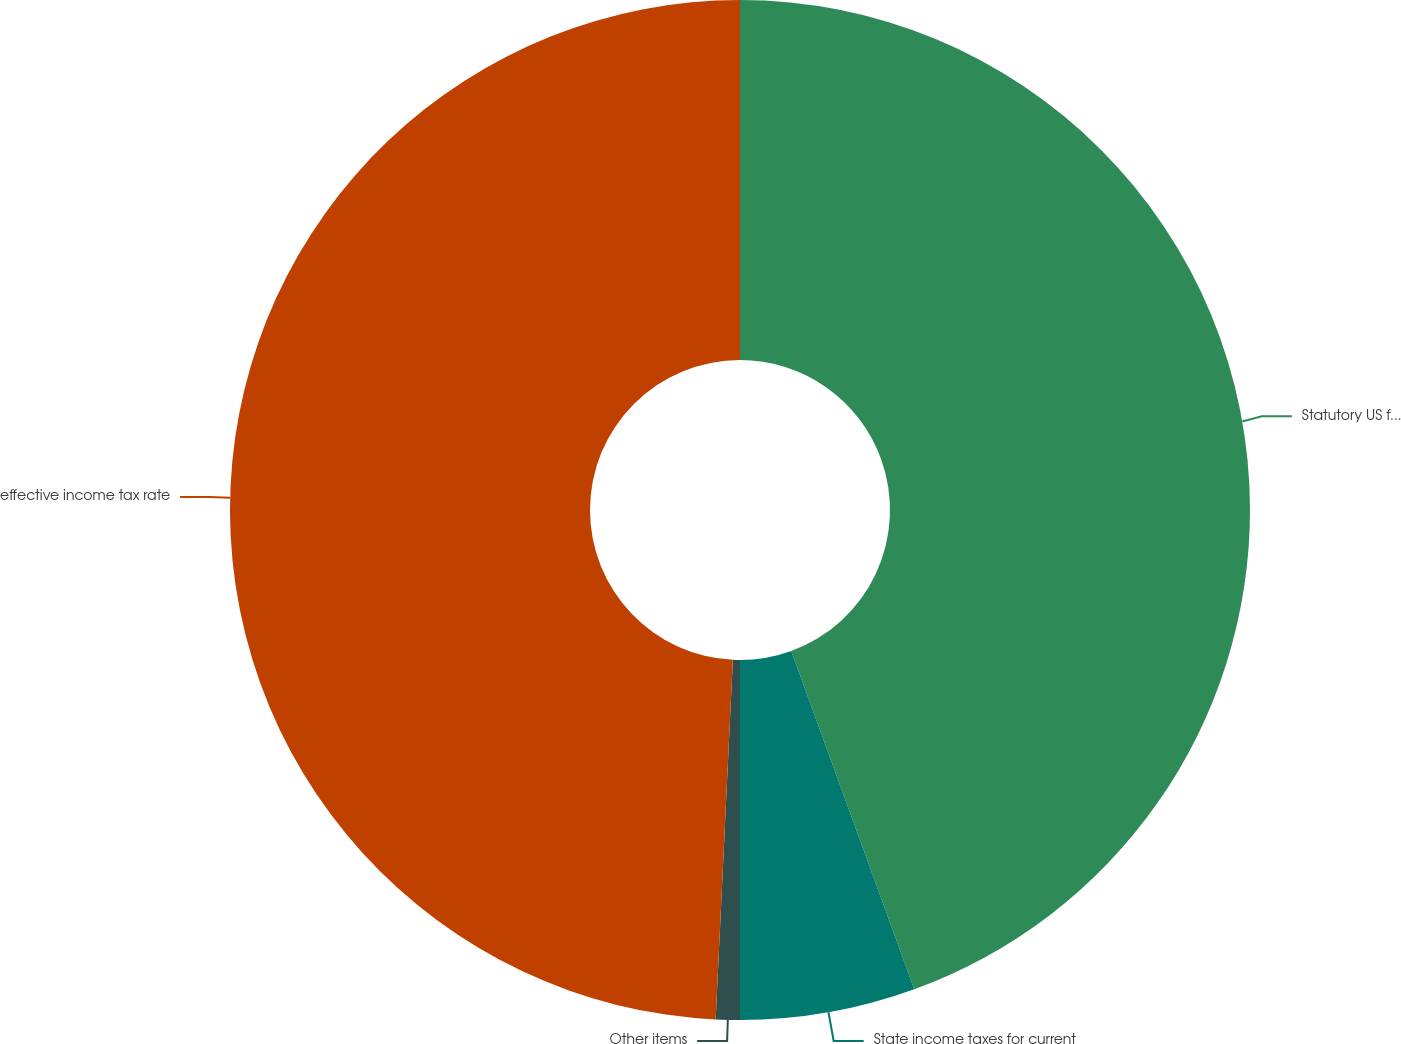<chart> <loc_0><loc_0><loc_500><loc_500><pie_chart><fcel>Statutory US federal income<fcel>State income taxes for current<fcel>Other items<fcel>effective income tax rate<nl><fcel>44.45%<fcel>5.55%<fcel>0.76%<fcel>49.24%<nl></chart> 